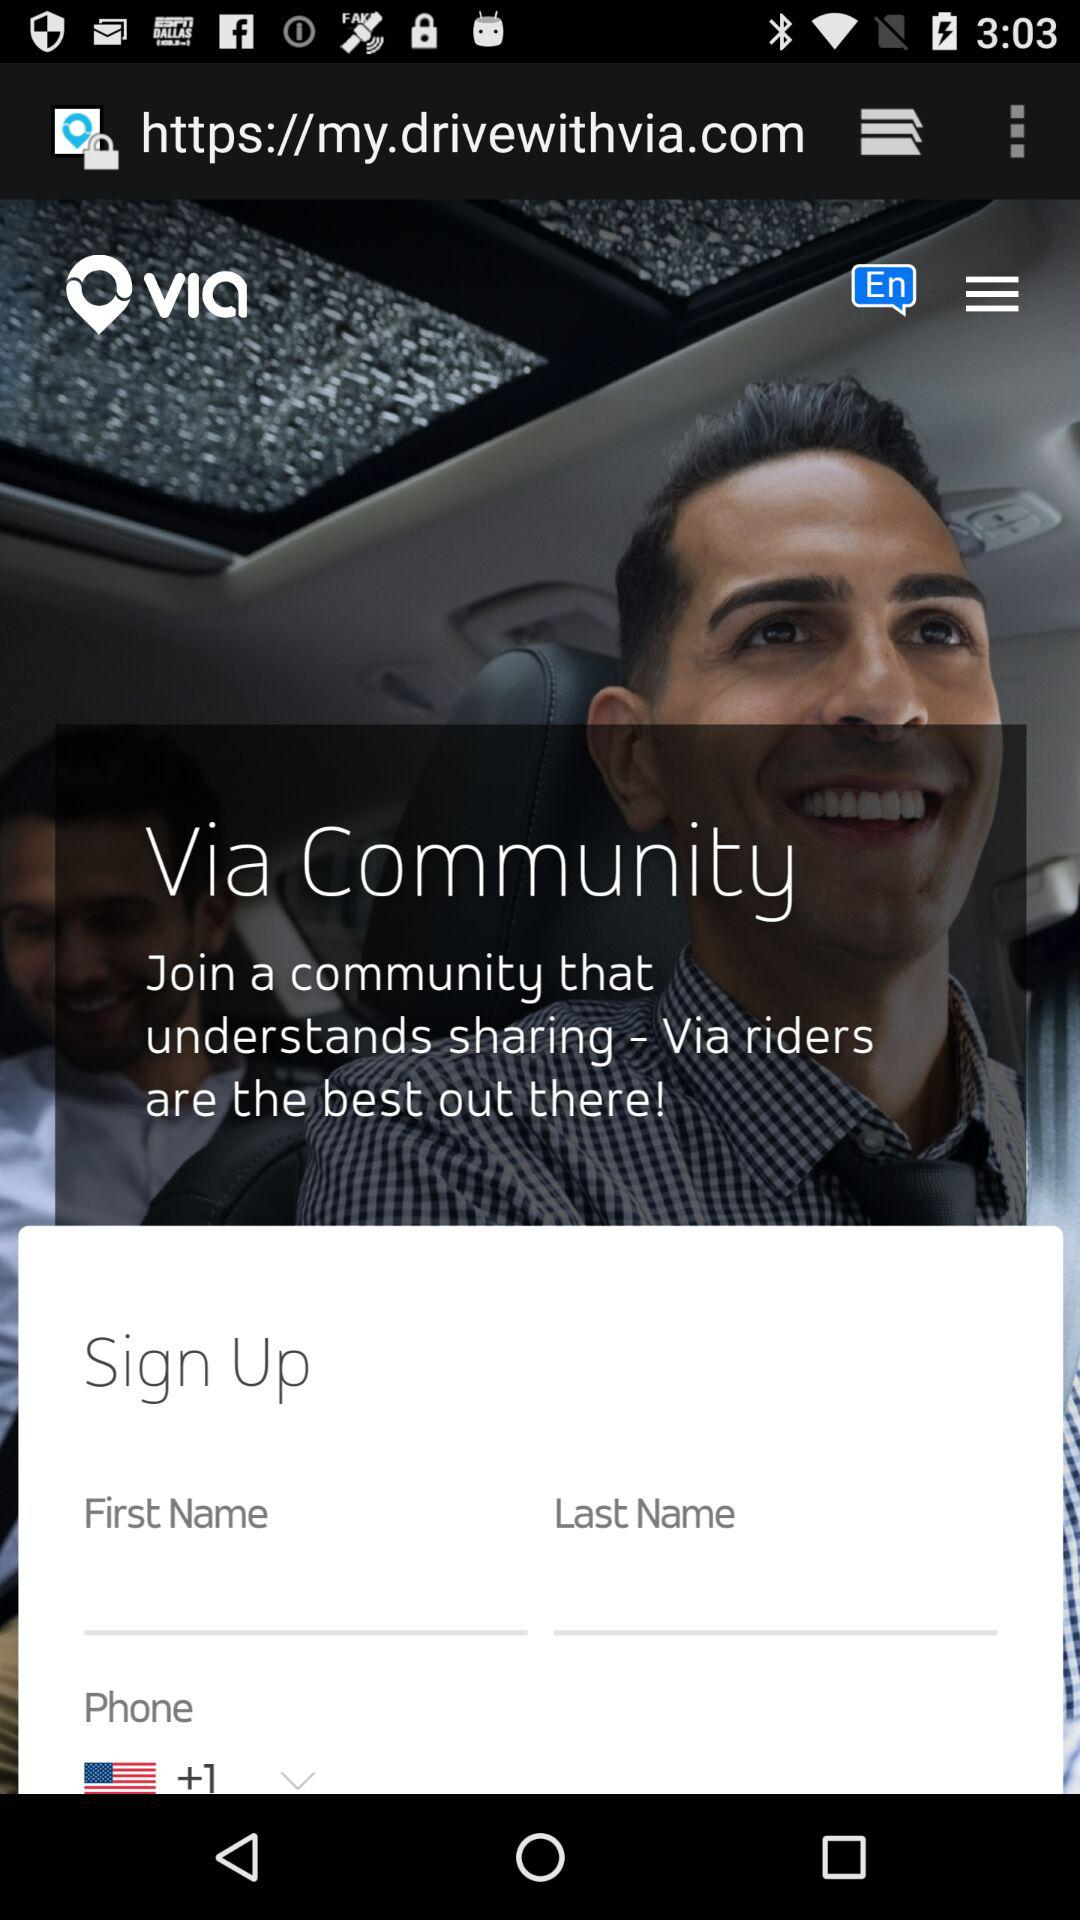What's the country code? The country code is +1. 